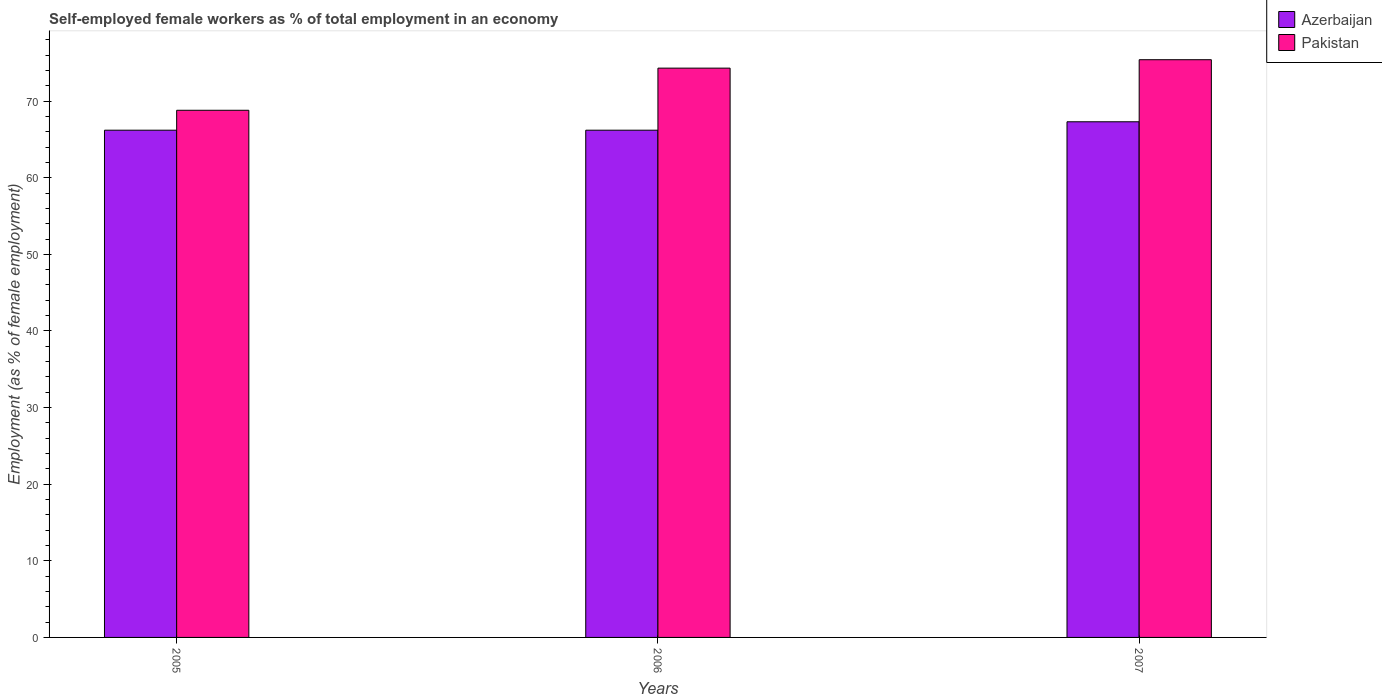How many bars are there on the 2nd tick from the left?
Offer a very short reply. 2. How many bars are there on the 3rd tick from the right?
Provide a short and direct response. 2. What is the percentage of self-employed female workers in Pakistan in 2007?
Provide a succinct answer. 75.4. Across all years, what is the maximum percentage of self-employed female workers in Pakistan?
Your answer should be very brief. 75.4. Across all years, what is the minimum percentage of self-employed female workers in Pakistan?
Ensure brevity in your answer.  68.8. In which year was the percentage of self-employed female workers in Azerbaijan minimum?
Keep it short and to the point. 2005. What is the total percentage of self-employed female workers in Pakistan in the graph?
Make the answer very short. 218.5. What is the difference between the percentage of self-employed female workers in Azerbaijan in 2006 and that in 2007?
Your answer should be compact. -1.1. What is the difference between the percentage of self-employed female workers in Pakistan in 2005 and the percentage of self-employed female workers in Azerbaijan in 2006?
Offer a terse response. 2.6. What is the average percentage of self-employed female workers in Pakistan per year?
Give a very brief answer. 72.83. In the year 2005, what is the difference between the percentage of self-employed female workers in Pakistan and percentage of self-employed female workers in Azerbaijan?
Your response must be concise. 2.6. In how many years, is the percentage of self-employed female workers in Pakistan greater than 8 %?
Provide a succinct answer. 3. What is the ratio of the percentage of self-employed female workers in Azerbaijan in 2005 to that in 2007?
Make the answer very short. 0.98. What is the difference between the highest and the second highest percentage of self-employed female workers in Pakistan?
Make the answer very short. 1.1. What is the difference between the highest and the lowest percentage of self-employed female workers in Pakistan?
Ensure brevity in your answer.  6.6. In how many years, is the percentage of self-employed female workers in Pakistan greater than the average percentage of self-employed female workers in Pakistan taken over all years?
Make the answer very short. 2. What does the 1st bar from the left in 2006 represents?
Your answer should be compact. Azerbaijan. What does the 2nd bar from the right in 2005 represents?
Your answer should be compact. Azerbaijan. How many bars are there?
Keep it short and to the point. 6. Are all the bars in the graph horizontal?
Your response must be concise. No. How many years are there in the graph?
Your answer should be compact. 3. Are the values on the major ticks of Y-axis written in scientific E-notation?
Provide a short and direct response. No. Does the graph contain any zero values?
Ensure brevity in your answer.  No. Where does the legend appear in the graph?
Offer a very short reply. Top right. How many legend labels are there?
Your answer should be compact. 2. What is the title of the graph?
Offer a terse response. Self-employed female workers as % of total employment in an economy. What is the label or title of the X-axis?
Your response must be concise. Years. What is the label or title of the Y-axis?
Provide a succinct answer. Employment (as % of female employment). What is the Employment (as % of female employment) of Azerbaijan in 2005?
Give a very brief answer. 66.2. What is the Employment (as % of female employment) of Pakistan in 2005?
Offer a very short reply. 68.8. What is the Employment (as % of female employment) in Azerbaijan in 2006?
Give a very brief answer. 66.2. What is the Employment (as % of female employment) in Pakistan in 2006?
Give a very brief answer. 74.3. What is the Employment (as % of female employment) in Azerbaijan in 2007?
Give a very brief answer. 67.3. What is the Employment (as % of female employment) of Pakistan in 2007?
Keep it short and to the point. 75.4. Across all years, what is the maximum Employment (as % of female employment) of Azerbaijan?
Provide a succinct answer. 67.3. Across all years, what is the maximum Employment (as % of female employment) in Pakistan?
Make the answer very short. 75.4. Across all years, what is the minimum Employment (as % of female employment) in Azerbaijan?
Keep it short and to the point. 66.2. Across all years, what is the minimum Employment (as % of female employment) in Pakistan?
Give a very brief answer. 68.8. What is the total Employment (as % of female employment) of Azerbaijan in the graph?
Ensure brevity in your answer.  199.7. What is the total Employment (as % of female employment) of Pakistan in the graph?
Your response must be concise. 218.5. What is the difference between the Employment (as % of female employment) in Azerbaijan in 2005 and that in 2006?
Keep it short and to the point. 0. What is the difference between the Employment (as % of female employment) of Azerbaijan in 2005 and that in 2007?
Offer a terse response. -1.1. What is the difference between the Employment (as % of female employment) of Pakistan in 2005 and that in 2007?
Your answer should be compact. -6.6. What is the difference between the Employment (as % of female employment) of Azerbaijan in 2006 and that in 2007?
Keep it short and to the point. -1.1. What is the difference between the Employment (as % of female employment) of Azerbaijan in 2005 and the Employment (as % of female employment) of Pakistan in 2007?
Your answer should be compact. -9.2. What is the average Employment (as % of female employment) in Azerbaijan per year?
Provide a short and direct response. 66.57. What is the average Employment (as % of female employment) of Pakistan per year?
Your response must be concise. 72.83. In the year 2005, what is the difference between the Employment (as % of female employment) in Azerbaijan and Employment (as % of female employment) in Pakistan?
Provide a succinct answer. -2.6. In the year 2006, what is the difference between the Employment (as % of female employment) of Azerbaijan and Employment (as % of female employment) of Pakistan?
Provide a succinct answer. -8.1. In the year 2007, what is the difference between the Employment (as % of female employment) in Azerbaijan and Employment (as % of female employment) in Pakistan?
Your answer should be very brief. -8.1. What is the ratio of the Employment (as % of female employment) of Pakistan in 2005 to that in 2006?
Keep it short and to the point. 0.93. What is the ratio of the Employment (as % of female employment) in Azerbaijan in 2005 to that in 2007?
Ensure brevity in your answer.  0.98. What is the ratio of the Employment (as % of female employment) of Pakistan in 2005 to that in 2007?
Provide a short and direct response. 0.91. What is the ratio of the Employment (as % of female employment) of Azerbaijan in 2006 to that in 2007?
Give a very brief answer. 0.98. What is the ratio of the Employment (as % of female employment) in Pakistan in 2006 to that in 2007?
Ensure brevity in your answer.  0.99. What is the difference between the highest and the second highest Employment (as % of female employment) of Azerbaijan?
Your answer should be compact. 1.1. What is the difference between the highest and the second highest Employment (as % of female employment) of Pakistan?
Provide a succinct answer. 1.1. What is the difference between the highest and the lowest Employment (as % of female employment) of Azerbaijan?
Offer a very short reply. 1.1. What is the difference between the highest and the lowest Employment (as % of female employment) of Pakistan?
Make the answer very short. 6.6. 